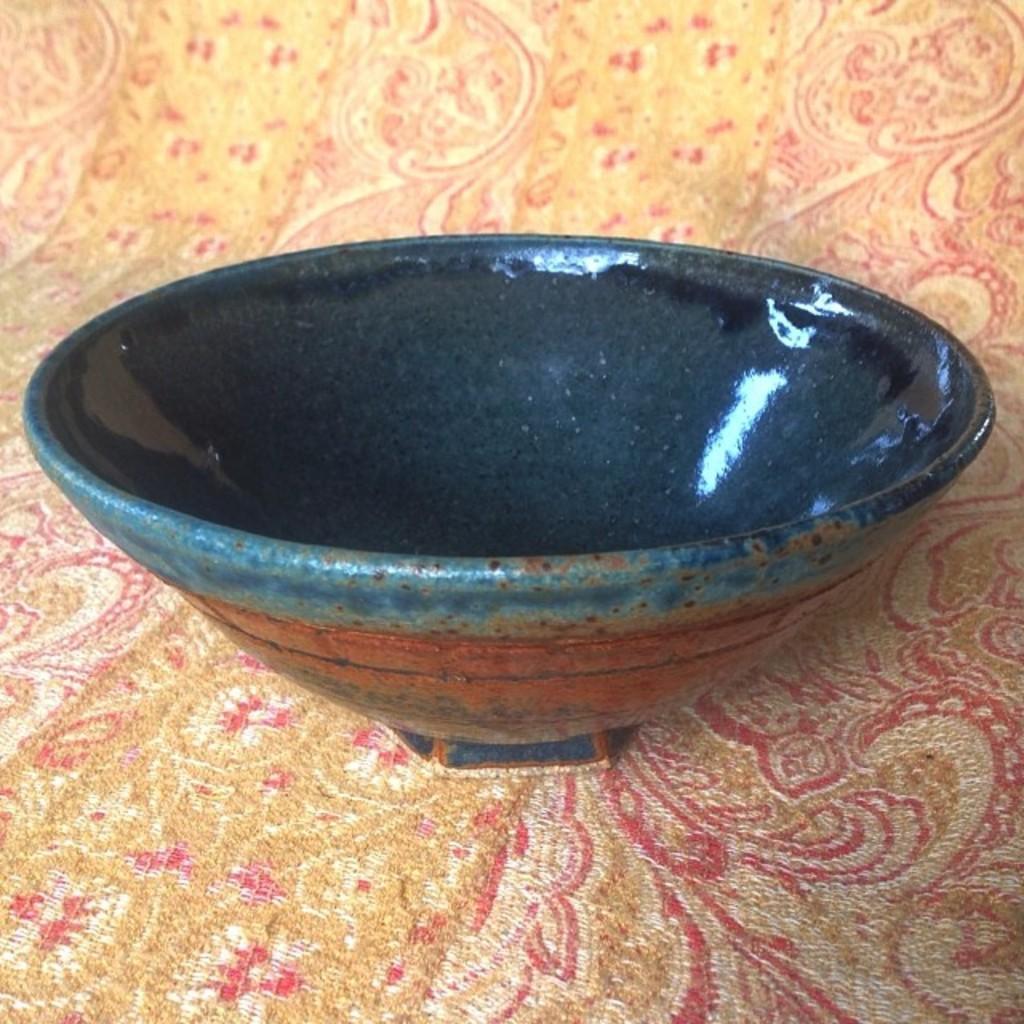How would you summarize this image in a sentence or two? In this image we can see a ceramic bowl. 